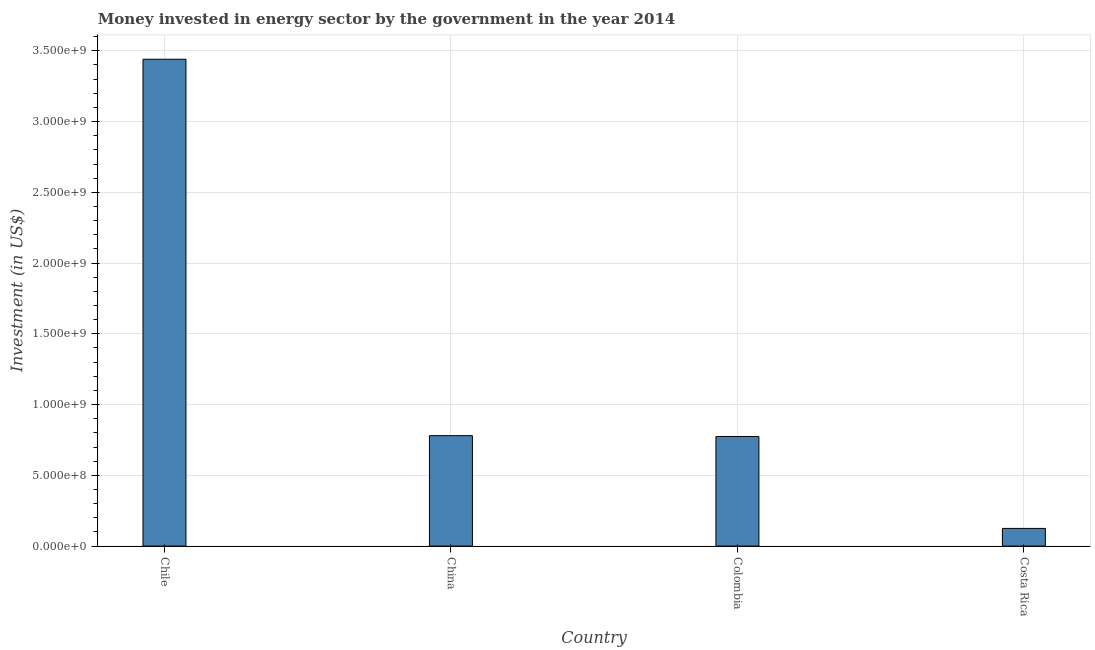Does the graph contain any zero values?
Ensure brevity in your answer.  No. What is the title of the graph?
Provide a succinct answer. Money invested in energy sector by the government in the year 2014. What is the label or title of the Y-axis?
Ensure brevity in your answer.  Investment (in US$). What is the investment in energy in Colombia?
Make the answer very short. 7.75e+08. Across all countries, what is the maximum investment in energy?
Keep it short and to the point. 3.44e+09. Across all countries, what is the minimum investment in energy?
Keep it short and to the point. 1.25e+08. In which country was the investment in energy maximum?
Your answer should be compact. Chile. In which country was the investment in energy minimum?
Keep it short and to the point. Costa Rica. What is the sum of the investment in energy?
Your answer should be very brief. 5.12e+09. What is the difference between the investment in energy in Chile and Colombia?
Your answer should be compact. 2.67e+09. What is the average investment in energy per country?
Your response must be concise. 1.28e+09. What is the median investment in energy?
Provide a succinct answer. 7.78e+08. What is the ratio of the investment in energy in Chile to that in China?
Make the answer very short. 4.41. What is the difference between the highest and the second highest investment in energy?
Your answer should be compact. 2.66e+09. What is the difference between the highest and the lowest investment in energy?
Ensure brevity in your answer.  3.32e+09. In how many countries, is the investment in energy greater than the average investment in energy taken over all countries?
Provide a succinct answer. 1. How many bars are there?
Your response must be concise. 4. Are all the bars in the graph horizontal?
Ensure brevity in your answer.  No. What is the Investment (in US$) in Chile?
Offer a terse response. 3.44e+09. What is the Investment (in US$) in China?
Give a very brief answer. 7.80e+08. What is the Investment (in US$) in Colombia?
Ensure brevity in your answer.  7.75e+08. What is the Investment (in US$) of Costa Rica?
Your answer should be very brief. 1.25e+08. What is the difference between the Investment (in US$) in Chile and China?
Offer a very short reply. 2.66e+09. What is the difference between the Investment (in US$) in Chile and Colombia?
Offer a very short reply. 2.67e+09. What is the difference between the Investment (in US$) in Chile and Costa Rica?
Your answer should be very brief. 3.32e+09. What is the difference between the Investment (in US$) in China and Colombia?
Keep it short and to the point. 5.85e+06. What is the difference between the Investment (in US$) in China and Costa Rica?
Make the answer very short. 6.55e+08. What is the difference between the Investment (in US$) in Colombia and Costa Rica?
Offer a terse response. 6.50e+08. What is the ratio of the Investment (in US$) in Chile to that in China?
Provide a succinct answer. 4.41. What is the ratio of the Investment (in US$) in Chile to that in Colombia?
Your answer should be compact. 4.44. What is the ratio of the Investment (in US$) in Chile to that in Costa Rica?
Offer a terse response. 27.53. What is the ratio of the Investment (in US$) in China to that in Colombia?
Your response must be concise. 1.01. What is the ratio of the Investment (in US$) in China to that in Costa Rica?
Ensure brevity in your answer.  6.24. What is the ratio of the Investment (in US$) in Colombia to that in Costa Rica?
Give a very brief answer. 6.2. 